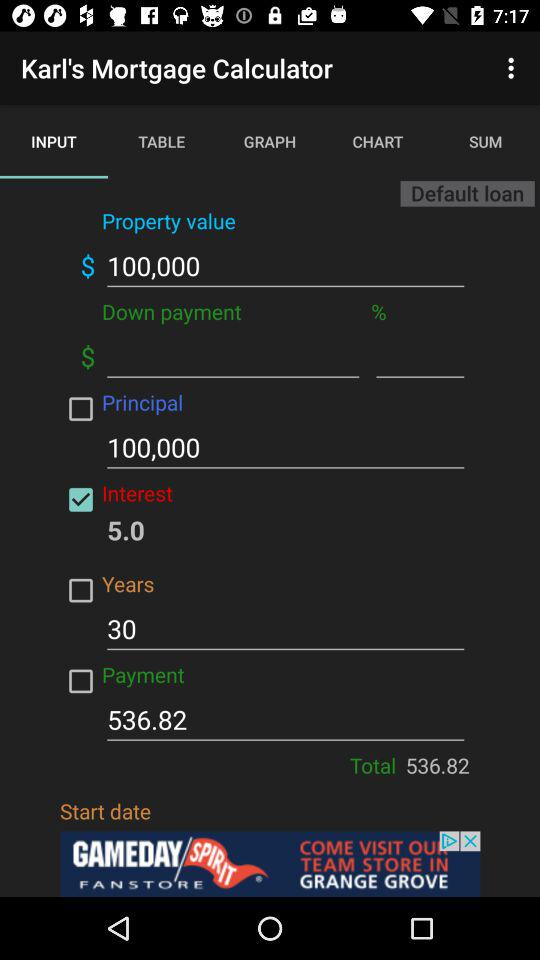What is the value of property? The value of property is $100,000. 